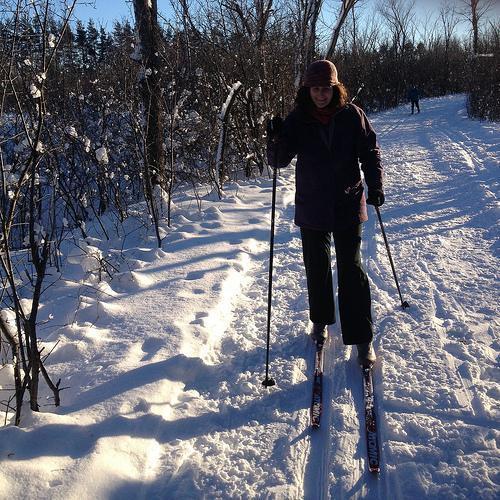How many people are visible?
Give a very brief answer. 2. 